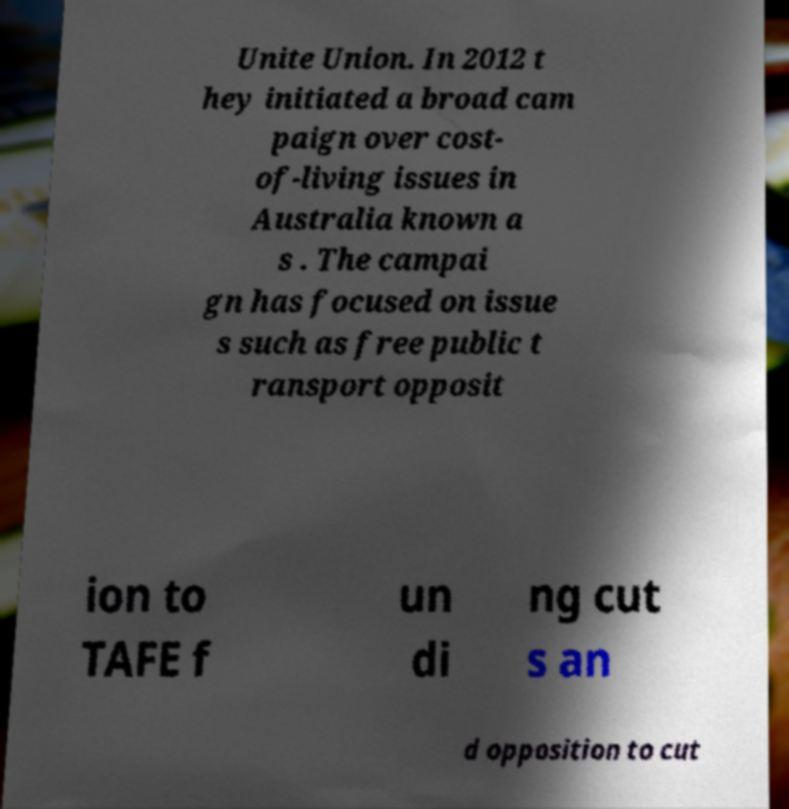Please read and relay the text visible in this image. What does it say? Unite Union. In 2012 t hey initiated a broad cam paign over cost- of-living issues in Australia known a s . The campai gn has focused on issue s such as free public t ransport opposit ion to TAFE f un di ng cut s an d opposition to cut 